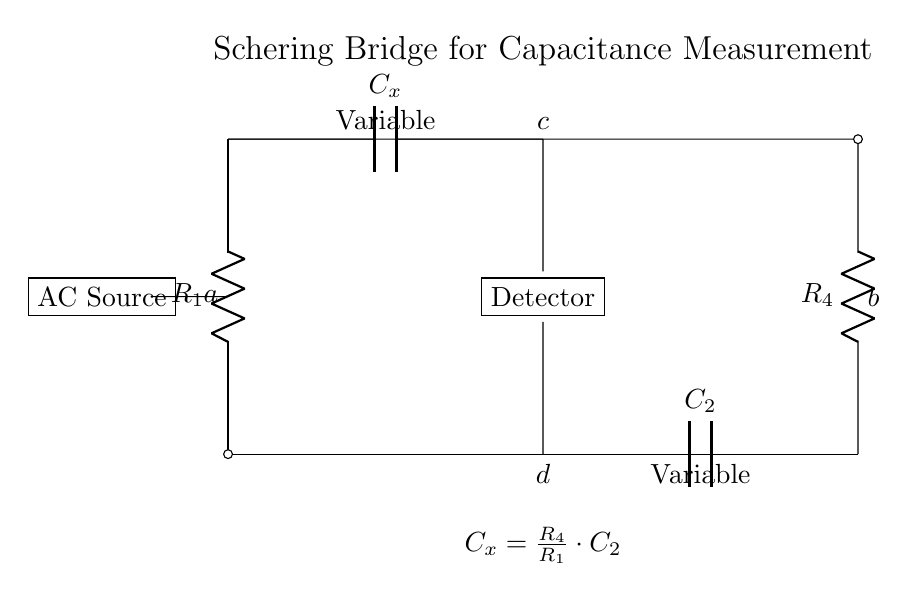What are the passive components in this circuit? The passive components include resistors and capacitors, specifically R1, R4, Cx, and C2.
Answer: Resistors and capacitors What does Cx represent in the Schering bridge? Cx represents the unknown capacitance that is being measured, which is a fundamental purpose of the Schering bridge circuit.
Answer: Unknown capacitance What is the relationship between Cx and C2 in this bridge? The relationship is defined by the formula Cx = (R4/R1) * C2, showing that Cx is dependent on the resistance values and C2.
Answer: Cx = (R4/R1) * C2 How many arms does the Schering bridge have? The Schering bridge has four arms, as indicated by the four distinct sections of the circuit diagram connecting to the nodes a, b, c, and d.
Answer: Four arms What is the purpose of the detector in the Schering bridge? The detector is used to determine the balance condition of the bridge, indicating when the network is in equilibrium and allowing for accurate measurement of Cx.
Answer: To measure balance What does the AC source provide to this circuit? The AC source provides the alternating current that is necessary for the bridge operation, ensuring oscillating voltage and current in the circuit to measure capacitance effectively.
Answer: Alternating current 